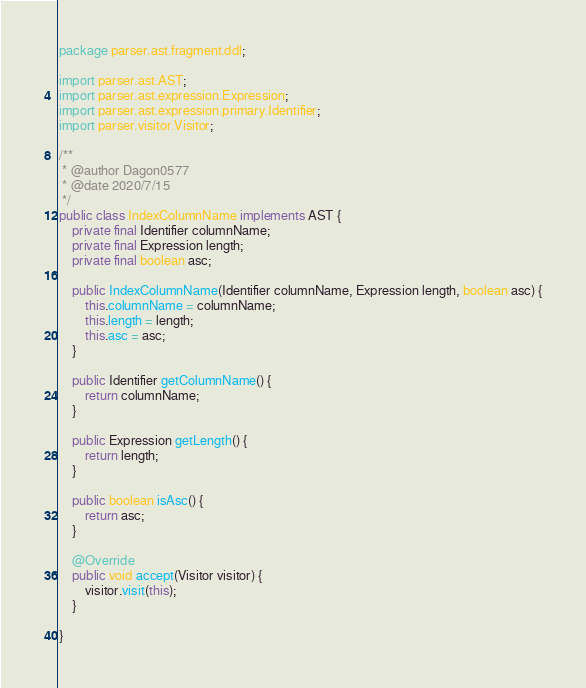<code> <loc_0><loc_0><loc_500><loc_500><_Java_>package parser.ast.fragment.ddl;

import parser.ast.AST;
import parser.ast.expression.Expression;
import parser.ast.expression.primary.Identifier;
import parser.visitor.Visitor;

/**
 * @author Dagon0577
 * @date 2020/7/15
 */
public class IndexColumnName implements AST {
    private final Identifier columnName;
    private final Expression length;
    private final boolean asc;

    public IndexColumnName(Identifier columnName, Expression length, boolean asc) {
        this.columnName = columnName;
        this.length = length;
        this.asc = asc;
    }

    public Identifier getColumnName() {
        return columnName;
    }

    public Expression getLength() {
        return length;
    }

    public boolean isAsc() {
        return asc;
    }

    @Override
    public void accept(Visitor visitor) {
        visitor.visit(this);
    }

}

</code> 